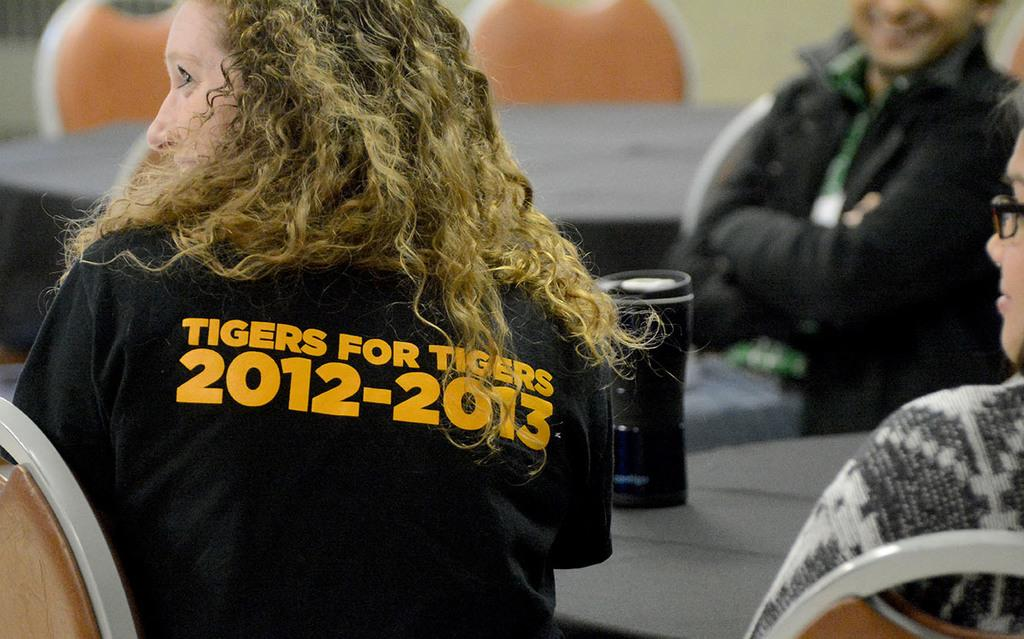What are the people in the image doing? The people in the image are sitting on chairs. Can you describe any objects in the image besides the chairs? Yes, there is a bottle in the image. How many houses can be seen in the image? There are no houses visible in the image; it only shows people sitting on chairs and a bottle. 